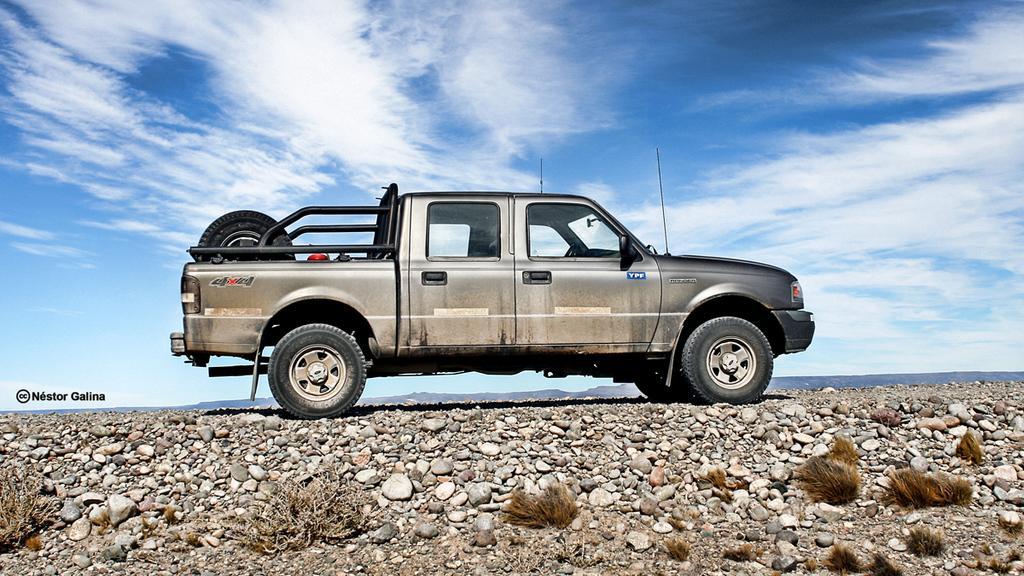How would you summarize this image in a sentence or two? In this picture there is a car. On the bottom we can see grass and stones. On the top we can see and clouds. Here we can see wheel on the car. On the left there is a watermark. 